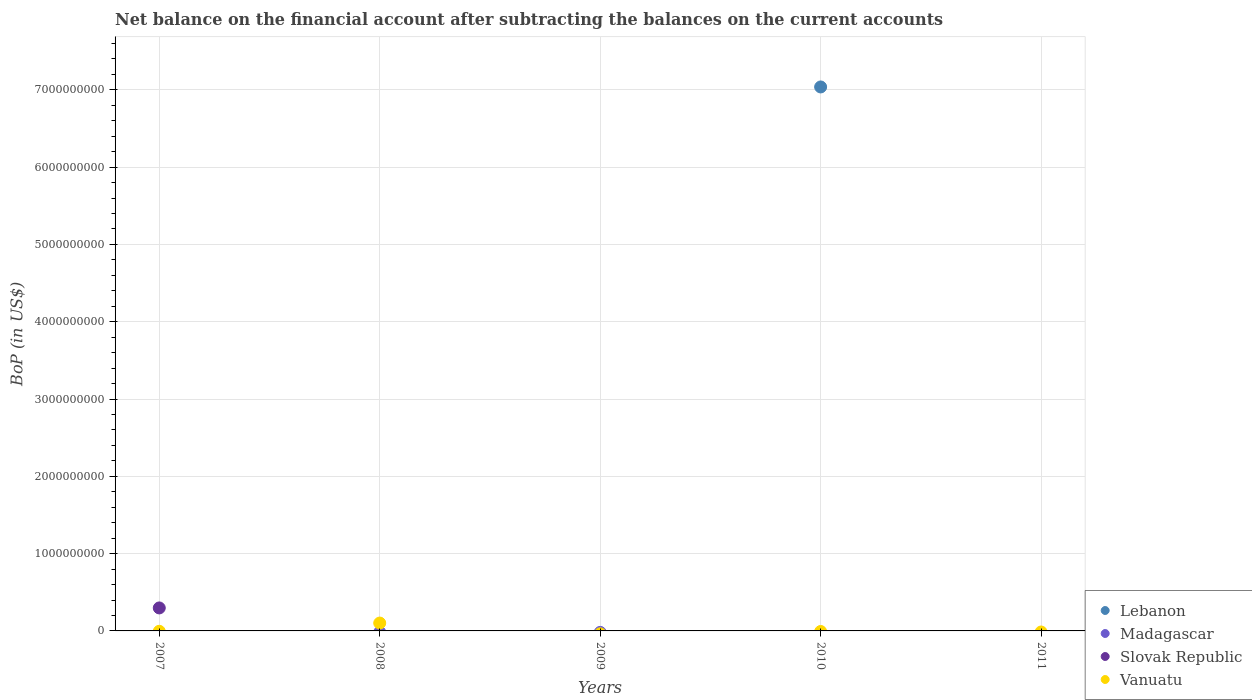How many different coloured dotlines are there?
Offer a terse response. 3. Across all years, what is the maximum Balance of Payments in Lebanon?
Your answer should be very brief. 7.04e+09. In which year was the Balance of Payments in Vanuatu maximum?
Offer a very short reply. 2008. What is the total Balance of Payments in Vanuatu in the graph?
Provide a succinct answer. 1.02e+08. What is the difference between the highest and the lowest Balance of Payments in Vanuatu?
Provide a short and direct response. 1.02e+08. Is it the case that in every year, the sum of the Balance of Payments in Vanuatu and Balance of Payments in Madagascar  is greater than the sum of Balance of Payments in Lebanon and Balance of Payments in Slovak Republic?
Make the answer very short. No. Is it the case that in every year, the sum of the Balance of Payments in Vanuatu and Balance of Payments in Madagascar  is greater than the Balance of Payments in Slovak Republic?
Give a very brief answer. No. Does the Balance of Payments in Vanuatu monotonically increase over the years?
Offer a terse response. No. How many years are there in the graph?
Give a very brief answer. 5. Are the values on the major ticks of Y-axis written in scientific E-notation?
Your response must be concise. No. Where does the legend appear in the graph?
Provide a succinct answer. Bottom right. How are the legend labels stacked?
Your answer should be compact. Vertical. What is the title of the graph?
Your response must be concise. Net balance on the financial account after subtracting the balances on the current accounts. What is the label or title of the X-axis?
Make the answer very short. Years. What is the label or title of the Y-axis?
Give a very brief answer. BoP (in US$). What is the BoP (in US$) in Lebanon in 2007?
Your answer should be very brief. 0. What is the BoP (in US$) of Slovak Republic in 2007?
Provide a succinct answer. 2.97e+08. What is the BoP (in US$) in Vanuatu in 2007?
Your answer should be compact. 0. What is the BoP (in US$) of Slovak Republic in 2008?
Offer a very short reply. 0. What is the BoP (in US$) in Vanuatu in 2008?
Your answer should be very brief. 1.02e+08. What is the BoP (in US$) in Lebanon in 2009?
Give a very brief answer. 0. What is the BoP (in US$) in Vanuatu in 2009?
Your answer should be very brief. 0. What is the BoP (in US$) in Lebanon in 2010?
Offer a very short reply. 7.04e+09. What is the BoP (in US$) in Madagascar in 2010?
Ensure brevity in your answer.  0. What is the BoP (in US$) in Slovak Republic in 2010?
Your answer should be compact. 0. What is the BoP (in US$) of Vanuatu in 2010?
Keep it short and to the point. 0. What is the BoP (in US$) in Madagascar in 2011?
Your answer should be compact. 0. Across all years, what is the maximum BoP (in US$) of Lebanon?
Make the answer very short. 7.04e+09. Across all years, what is the maximum BoP (in US$) in Slovak Republic?
Give a very brief answer. 2.97e+08. Across all years, what is the maximum BoP (in US$) of Vanuatu?
Keep it short and to the point. 1.02e+08. Across all years, what is the minimum BoP (in US$) in Lebanon?
Keep it short and to the point. 0. Across all years, what is the minimum BoP (in US$) in Slovak Republic?
Your response must be concise. 0. Across all years, what is the minimum BoP (in US$) in Vanuatu?
Keep it short and to the point. 0. What is the total BoP (in US$) in Lebanon in the graph?
Your answer should be compact. 7.04e+09. What is the total BoP (in US$) in Slovak Republic in the graph?
Ensure brevity in your answer.  2.97e+08. What is the total BoP (in US$) in Vanuatu in the graph?
Make the answer very short. 1.02e+08. What is the difference between the BoP (in US$) of Slovak Republic in 2007 and the BoP (in US$) of Vanuatu in 2008?
Your answer should be very brief. 1.95e+08. What is the average BoP (in US$) of Lebanon per year?
Provide a succinct answer. 1.41e+09. What is the average BoP (in US$) of Madagascar per year?
Offer a terse response. 0. What is the average BoP (in US$) of Slovak Republic per year?
Offer a very short reply. 5.95e+07. What is the average BoP (in US$) in Vanuatu per year?
Offer a very short reply. 2.04e+07. What is the difference between the highest and the lowest BoP (in US$) of Lebanon?
Ensure brevity in your answer.  7.04e+09. What is the difference between the highest and the lowest BoP (in US$) in Slovak Republic?
Ensure brevity in your answer.  2.97e+08. What is the difference between the highest and the lowest BoP (in US$) of Vanuatu?
Your answer should be compact. 1.02e+08. 